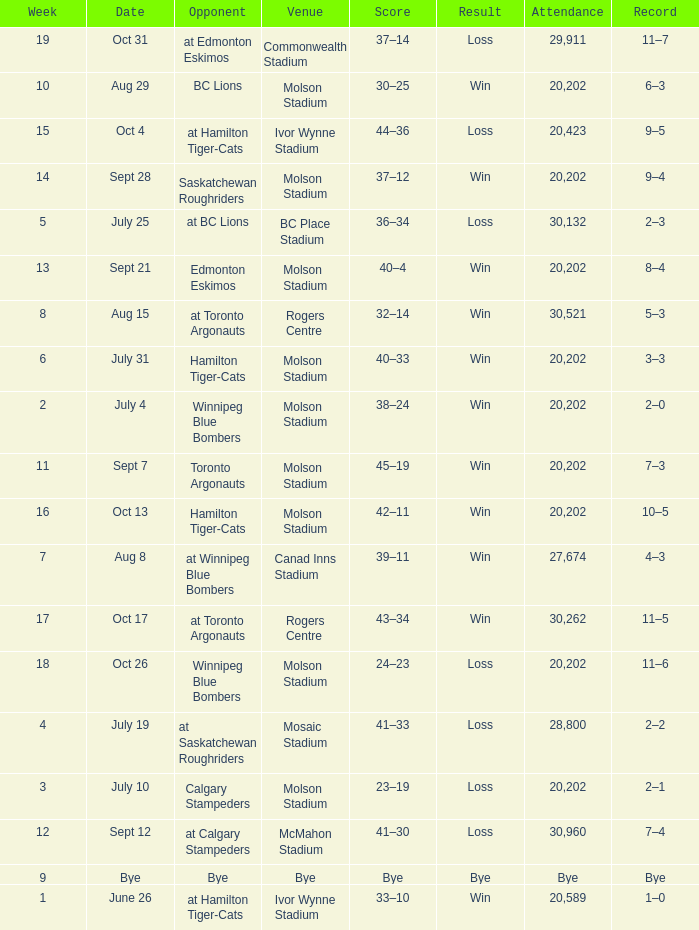What is Opponent, when Result is Loss, and when Venue is Mosaic Stadium? At saskatchewan roughriders. 